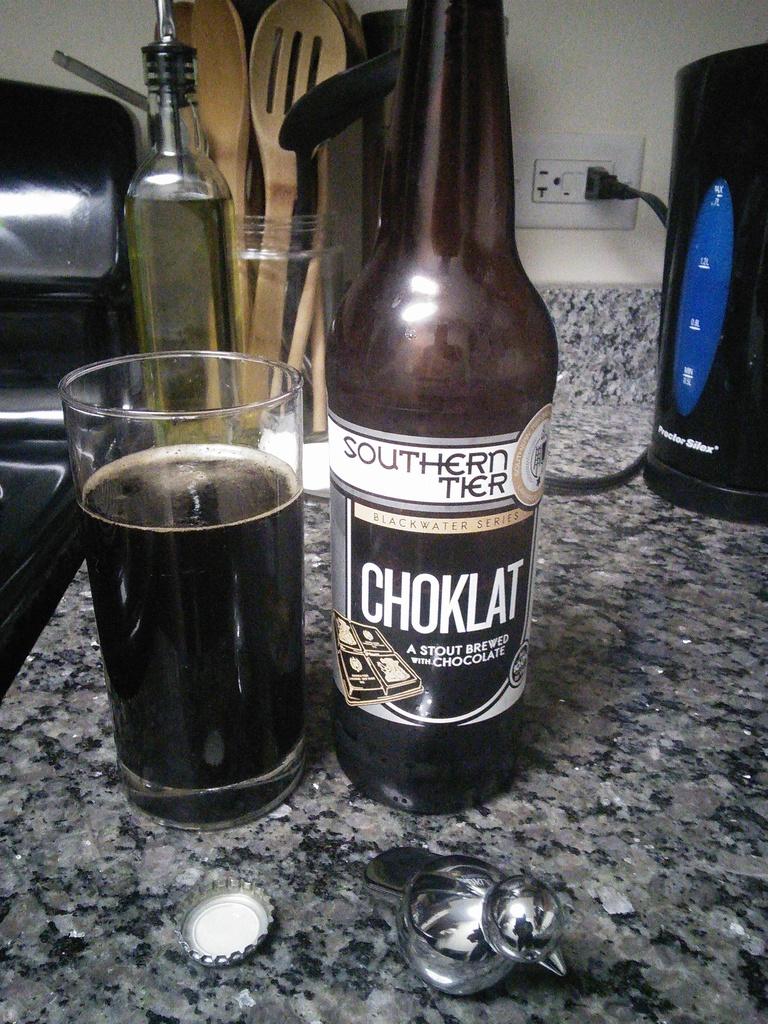What does this beer taste like?
Offer a terse response. Chocolate. What is the top word?
Provide a succinct answer. Southern. 